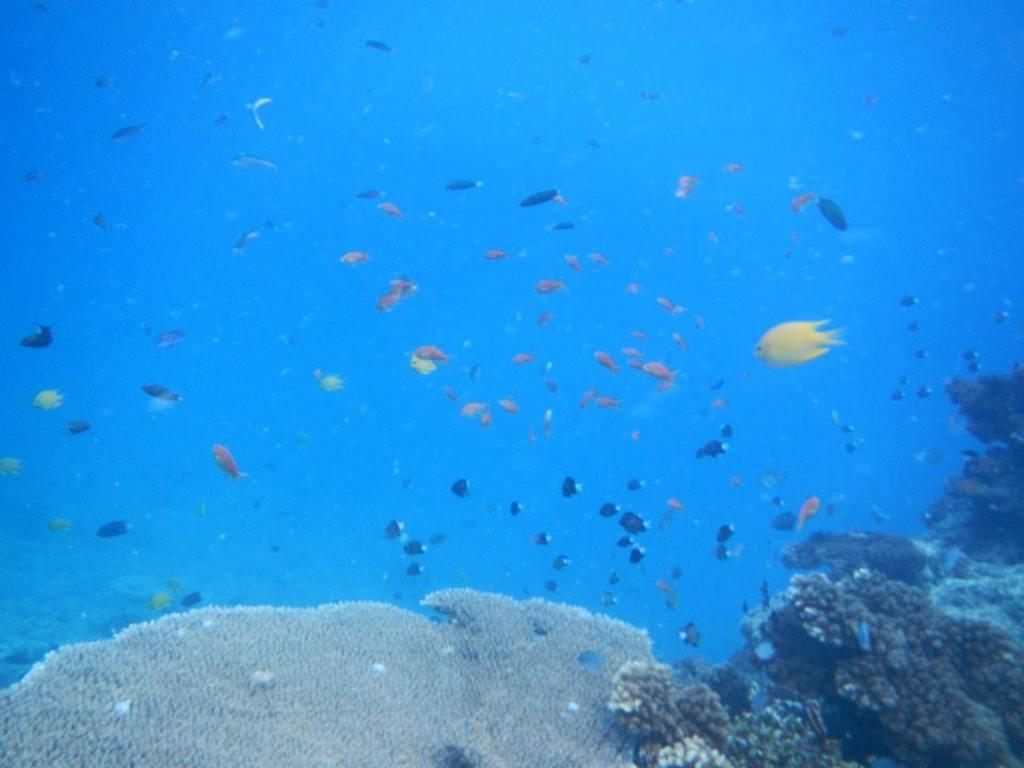What type of animals can be seen in the image? There are fishes swimming in the image. Where are the fishes located? The fishes are in the water. What else can be found in the water in the image? There are aquatic plants under the water in the image. Can you see the bird taking a recess in the image? There is no bird or recess present in the image; it features fishes swimming in the water with aquatic plants. 